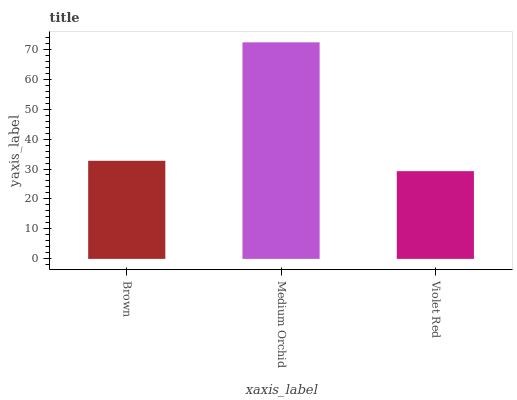Is Violet Red the minimum?
Answer yes or no. Yes. Is Medium Orchid the maximum?
Answer yes or no. Yes. Is Medium Orchid the minimum?
Answer yes or no. No. Is Violet Red the maximum?
Answer yes or no. No. Is Medium Orchid greater than Violet Red?
Answer yes or no. Yes. Is Violet Red less than Medium Orchid?
Answer yes or no. Yes. Is Violet Red greater than Medium Orchid?
Answer yes or no. No. Is Medium Orchid less than Violet Red?
Answer yes or no. No. Is Brown the high median?
Answer yes or no. Yes. Is Brown the low median?
Answer yes or no. Yes. Is Medium Orchid the high median?
Answer yes or no. No. Is Violet Red the low median?
Answer yes or no. No. 